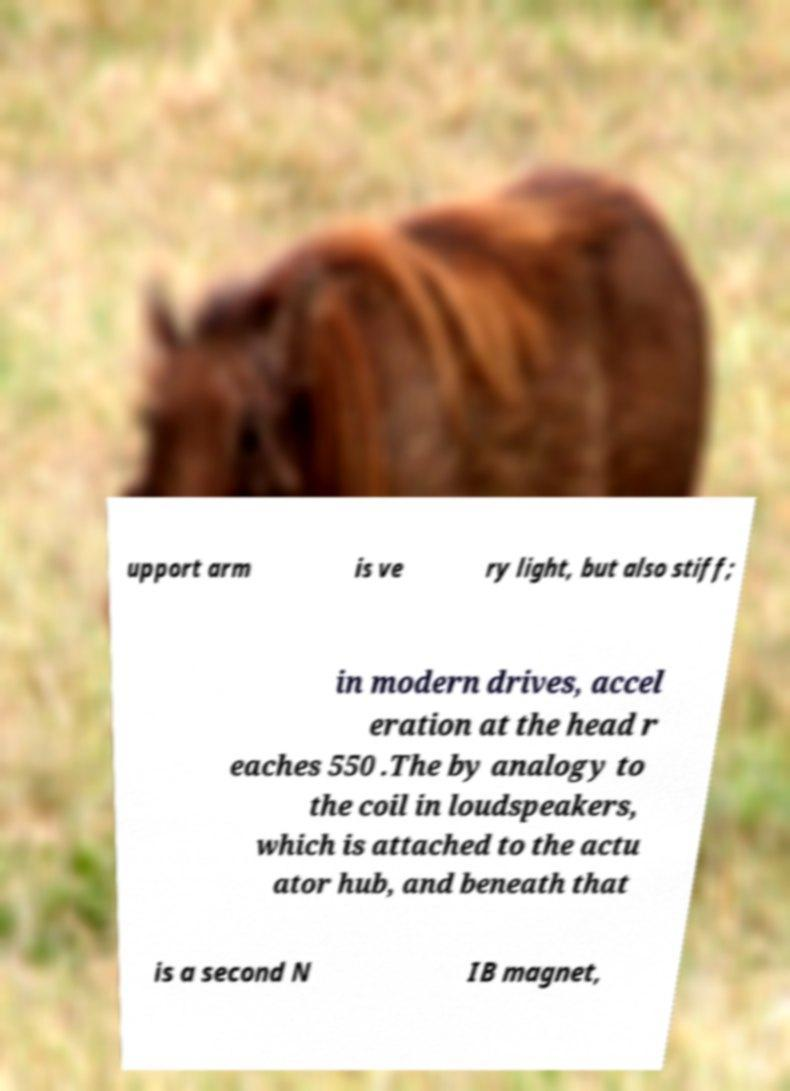I need the written content from this picture converted into text. Can you do that? upport arm is ve ry light, but also stiff; in modern drives, accel eration at the head r eaches 550 .The by analogy to the coil in loudspeakers, which is attached to the actu ator hub, and beneath that is a second N IB magnet, 